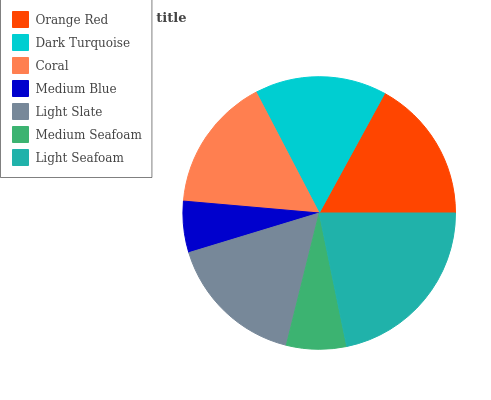Is Medium Blue the minimum?
Answer yes or no. Yes. Is Light Seafoam the maximum?
Answer yes or no. Yes. Is Dark Turquoise the minimum?
Answer yes or no. No. Is Dark Turquoise the maximum?
Answer yes or no. No. Is Orange Red greater than Dark Turquoise?
Answer yes or no. Yes. Is Dark Turquoise less than Orange Red?
Answer yes or no. Yes. Is Dark Turquoise greater than Orange Red?
Answer yes or no. No. Is Orange Red less than Dark Turquoise?
Answer yes or no. No. Is Coral the high median?
Answer yes or no. Yes. Is Coral the low median?
Answer yes or no. Yes. Is Medium Blue the high median?
Answer yes or no. No. Is Light Seafoam the low median?
Answer yes or no. No. 